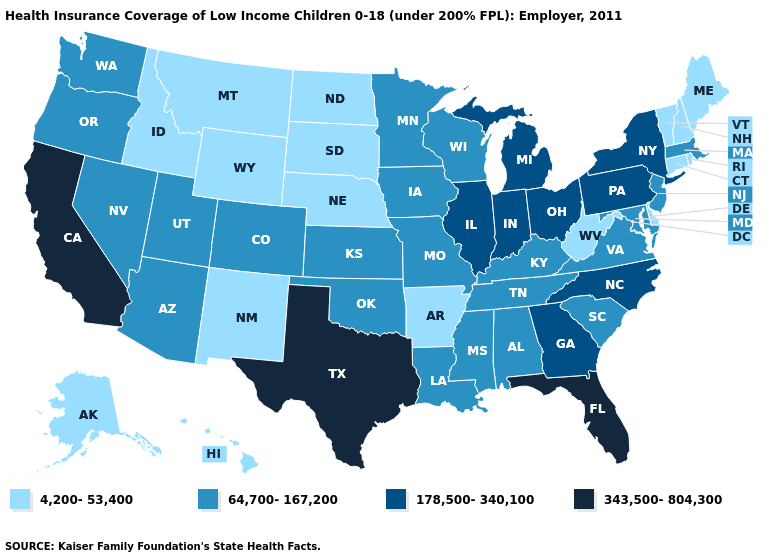What is the highest value in the USA?
Short answer required. 343,500-804,300. What is the value of Georgia?
Answer briefly. 178,500-340,100. What is the lowest value in the West?
Concise answer only. 4,200-53,400. Which states have the lowest value in the USA?
Short answer required. Alaska, Arkansas, Connecticut, Delaware, Hawaii, Idaho, Maine, Montana, Nebraska, New Hampshire, New Mexico, North Dakota, Rhode Island, South Dakota, Vermont, West Virginia, Wyoming. What is the highest value in states that border Washington?
Quick response, please. 64,700-167,200. Among the states that border New Jersey , does Delaware have the lowest value?
Short answer required. Yes. Does the first symbol in the legend represent the smallest category?
Answer briefly. Yes. Name the states that have a value in the range 4,200-53,400?
Keep it brief. Alaska, Arkansas, Connecticut, Delaware, Hawaii, Idaho, Maine, Montana, Nebraska, New Hampshire, New Mexico, North Dakota, Rhode Island, South Dakota, Vermont, West Virginia, Wyoming. Is the legend a continuous bar?
Be succinct. No. Which states have the lowest value in the MidWest?
Be succinct. Nebraska, North Dakota, South Dakota. What is the lowest value in the USA?
Answer briefly. 4,200-53,400. Among the states that border North Carolina , does Georgia have the lowest value?
Short answer required. No. Does the map have missing data?
Answer briefly. No. What is the value of Maryland?
Give a very brief answer. 64,700-167,200. Does Texas have the highest value in the South?
Concise answer only. Yes. 